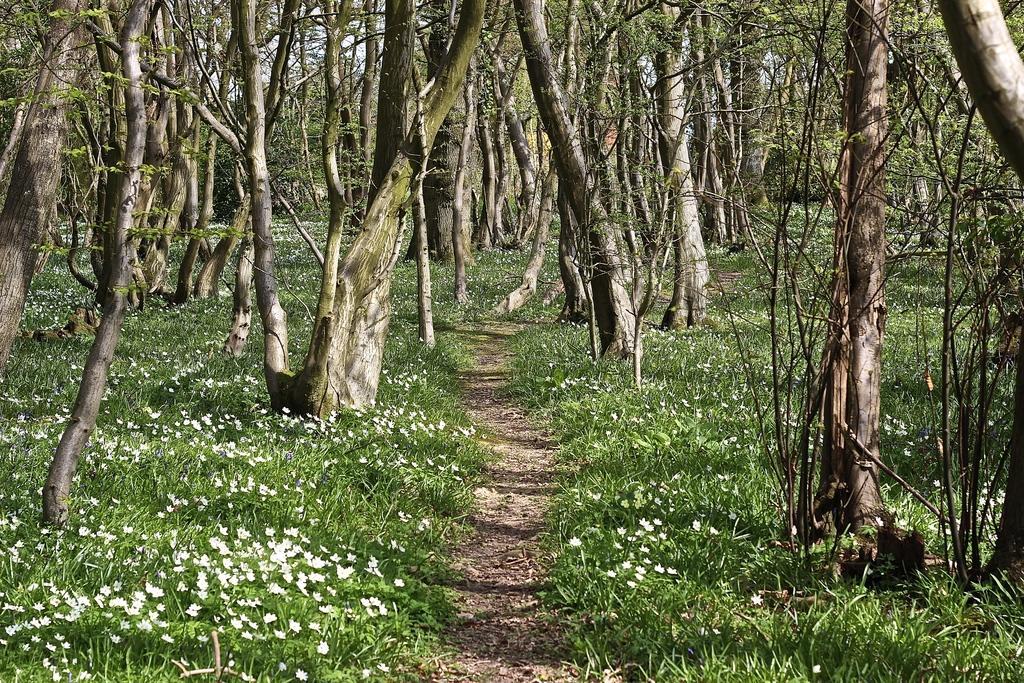Could you give a brief overview of what you see in this image? In the image there are many trees and in between the trees there is a lot of grass with some flowers. 